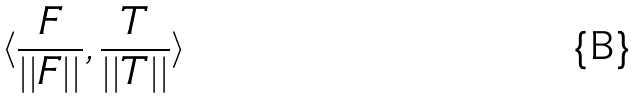<formula> <loc_0><loc_0><loc_500><loc_500>\langle \frac { F } { | | F | | } , \frac { T } { | | T | | } \rangle</formula> 